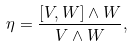<formula> <loc_0><loc_0><loc_500><loc_500>\eta = \frac { [ V , W ] \wedge W } { V \wedge W } ,</formula> 